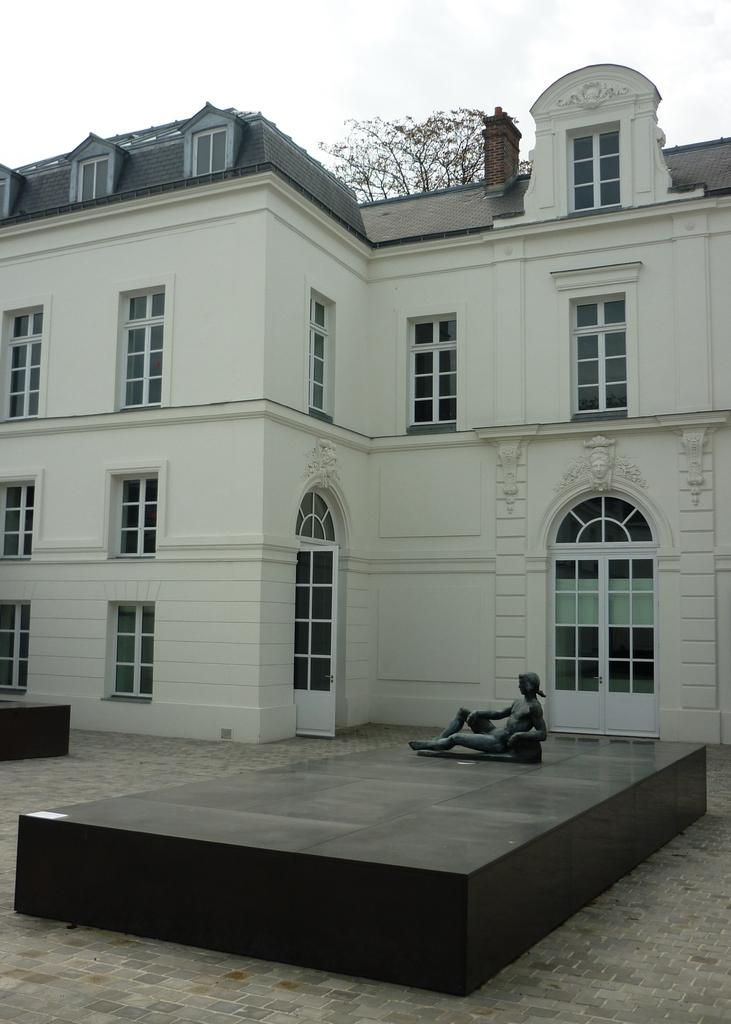What type of structure is present in the image? There is a building in the image. What feature can be seen on the building? The building has windows. What is located in front of the building? There is a statue in front of the building. What can be seen above the building and statue? The sky is visible above the building and statue. What color is the gold hand that is blowing the wind in the image? There is no gold hand or wind present in the image. 